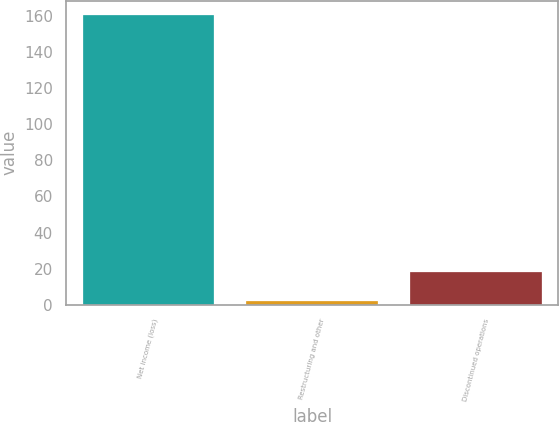Convert chart. <chart><loc_0><loc_0><loc_500><loc_500><bar_chart><fcel>Net income (loss)<fcel>Restructuring and other<fcel>Discontinued operations<nl><fcel>160.2<fcel>2.2<fcel>18<nl></chart> 